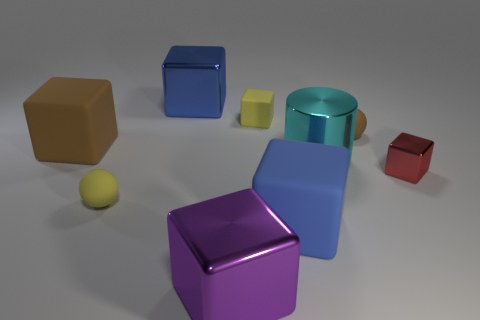Subtract all tiny red blocks. How many blocks are left? 5 Subtract all yellow blocks. How many blocks are left? 5 Subtract all cyan cubes. Subtract all red cylinders. How many cubes are left? 6 Add 1 tiny red blocks. How many objects exist? 10 Subtract all blocks. How many objects are left? 3 Add 3 matte cubes. How many matte cubes are left? 6 Add 2 small rubber cubes. How many small rubber cubes exist? 3 Subtract 1 brown balls. How many objects are left? 8 Subtract all big blue things. Subtract all yellow things. How many objects are left? 5 